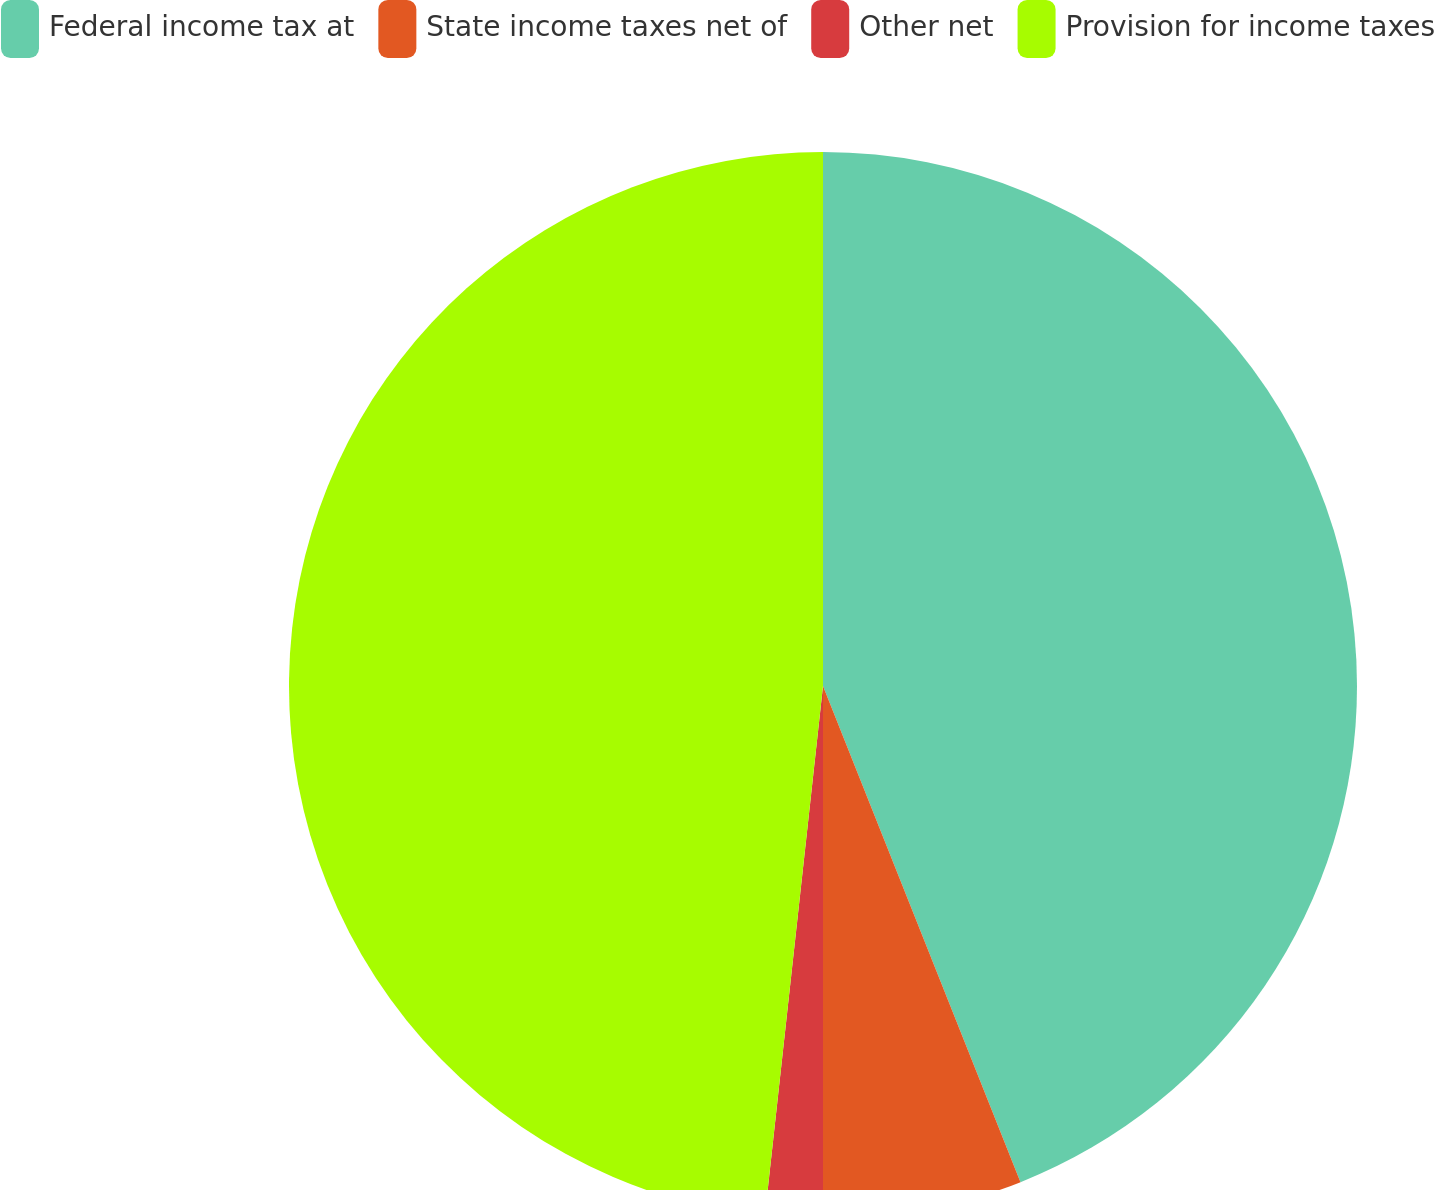<chart> <loc_0><loc_0><loc_500><loc_500><pie_chart><fcel>Federal income tax at<fcel>State income taxes net of<fcel>Other net<fcel>Provision for income taxes<nl><fcel>43.97%<fcel>6.03%<fcel>1.74%<fcel>48.26%<nl></chart> 